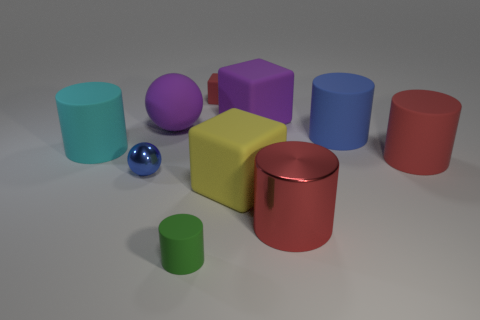Subtract all large rubber blocks. How many blocks are left? 1 Add 7 small balls. How many small balls exist? 8 Subtract all blue cylinders. How many cylinders are left? 4 Subtract 0 red balls. How many objects are left? 10 Subtract all cubes. How many objects are left? 7 Subtract 3 blocks. How many blocks are left? 0 Subtract all brown cylinders. Subtract all cyan blocks. How many cylinders are left? 5 Subtract all purple spheres. How many brown cylinders are left? 0 Subtract all tiny blue matte objects. Subtract all red matte objects. How many objects are left? 8 Add 8 red cylinders. How many red cylinders are left? 10 